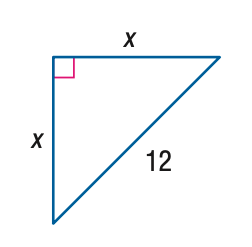Answer the mathemtical geometry problem and directly provide the correct option letter.
Question: Find x.
Choices: A: 6 \sqrt { 2 } B: 6 \sqrt { 3 } C: 12 \sqrt { 2 } D: 12 \sqrt { 3 } A 